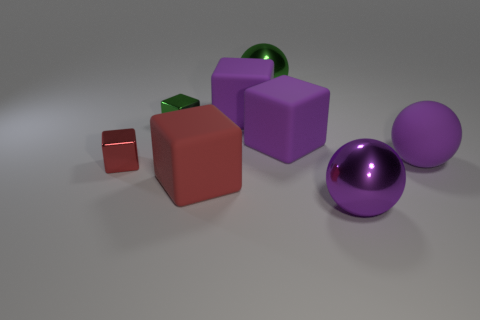Subtract all red cubes. Subtract all green cylinders. How many cubes are left? 3 Subtract all blue cylinders. How many red cubes are left? 2 Add 4 tiny things. How many reds exist? 0 Subtract all purple matte balls. Subtract all large green things. How many objects are left? 6 Add 1 big red matte things. How many big red matte things are left? 2 Add 8 red metallic things. How many red metallic things exist? 9 Add 2 yellow matte objects. How many objects exist? 10 Subtract all purple cubes. How many cubes are left? 3 Subtract all shiny cubes. How many cubes are left? 3 Subtract 2 purple spheres. How many objects are left? 6 